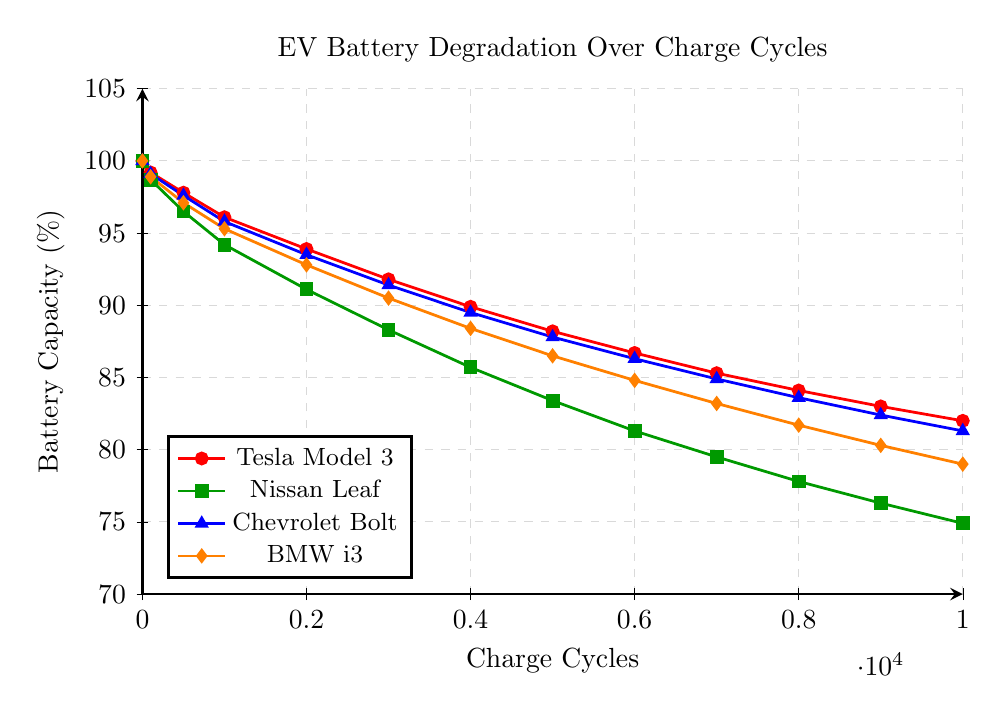Which EV model shows the highest battery capacity at 10000 charge cycles? The green line representing the Nissan Leaf has the lowest battery capacity on the y-axis at 10000 charge cycles, compared to others.
Answer: Tesla Model 3 How much battery capacity did the BMW i3 lose between 0 and 5000 charge cycles? The battery capacity of BMW i3 at 0 charge cycles is 100%, and at 5000 charge cycles, it is 86.5%. So, the loss is 100% - 86.5% = 13.5%.
Answer: 13.5% Which EV model shows the most significant degradation after 5000 charge cycles? By comparing the battery capacities at 5000 charge cycles for all models, the Nissan Leaf (green line) shows the lowest battery capacity at 83.4%, indicating the most significant degradation.
Answer: Nissan Leaf Between the Chevrolet Bolt and BMW i3, which one has a higher battery capacity at 3000 charge cycles? The battery capacity for the Chevrolet Bolt (blue line) at 3000 charge cycles is 91.4%, while the BMW i3 (orange line) is 90.5%.
Answer: Chevrolet Bolt What is the average battery capacity for the Tesla Model 3 at 0, 5000, and 10000 charge cycles? The battery capacities for Tesla Model 3 at 0, 5000, and 10000 charge cycles are 100%, 88.2%, and 82.0% respectively. The average is (100 + 88.2 + 82.0) / 3 = 90.07%.
Answer: 90.07% Which two EV models show a similar battery capacity trend over the charge cycles? By examining the patterns visually, the Chevrolet Bolt (blue line) and BMW i3 (orange line) lines appear to have a similar decline in battery capacity over charge cycles.
Answer: Chevrolet Bolt and BMW i3 At 7000 charge cycles, which EV model has the lowest battery capacity, and what is its value? The green line representing the Nissan Leaf shows the lowest battery capacity at 7000 charge cycles, with a value of 79.5%.
Answer: Nissan Leaf, 79.5% How does the battery capacity of the Nissan Leaf at 1000 charge cycles compare to the Chevrolet Bolt at the same point? At 1000 charge cycles, the Nissan Leaf (green line) has a battery capacity of 94.2%, while the Chevrolet Bolt (blue line) has 95.8%, which is higher.
Answer: Chevrolet Bolt has higher battery capacity at 1000 cycles What is the difference in battery capacity decline from 0 to 9000 charge cycles between Tesla Model 3 and Nissan Leaf? Tesla Model 3 declines from 100% to 83.0%, a drop of 17.0% (100 - 83). Nissan Leaf declines from 100% to 76.3%, a drop of 23.7% (100 - 76.3). Difference in decline is 23.7% - 17.0% = 6.7%.
Answer: 6.7% Which EV model has the most consistent rate of battery degradation over 10000 charge cycles? Visually, the red line representing Tesla Model 3 displays the most linear and consistent decline in battery capacity over 10000 charge cycles.
Answer: Tesla Model 3 